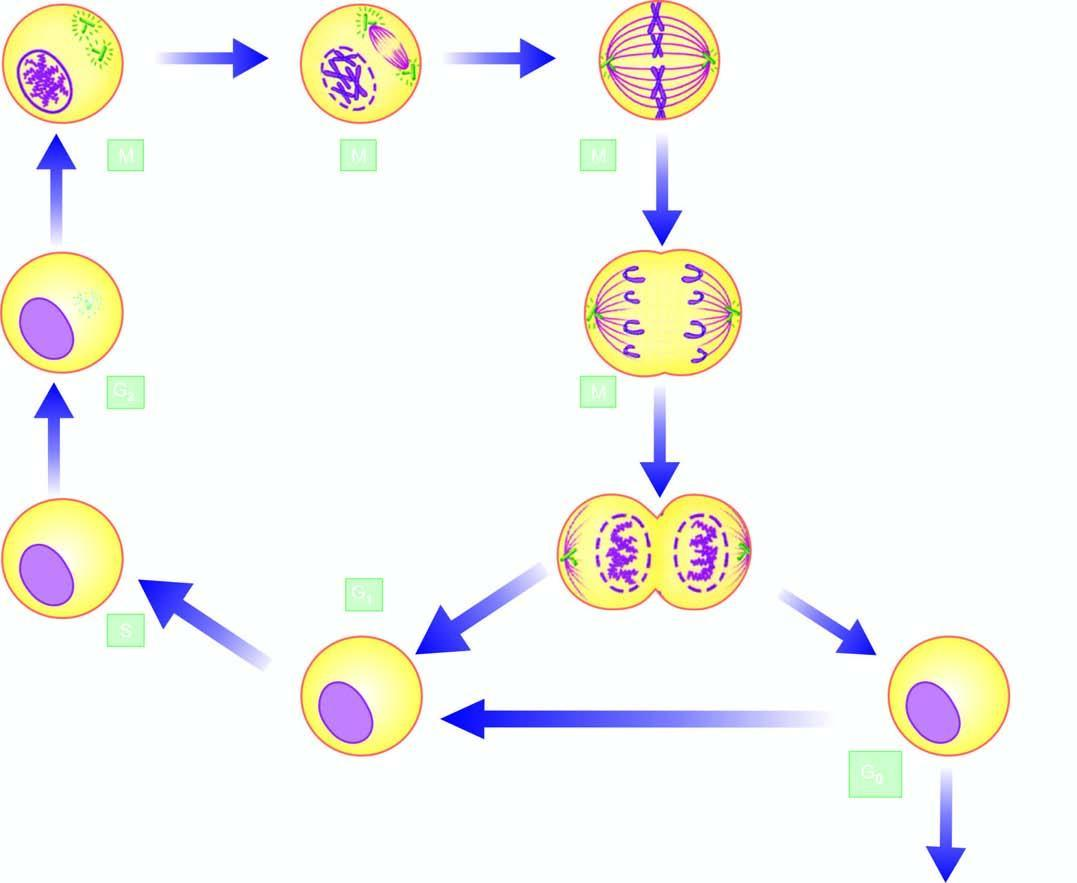s m (mitotic) phase accomplished in 4 sequential stages: prophase, metaphase, anaphase, and telophase?
Answer the question using a single word or phrase. Yes 